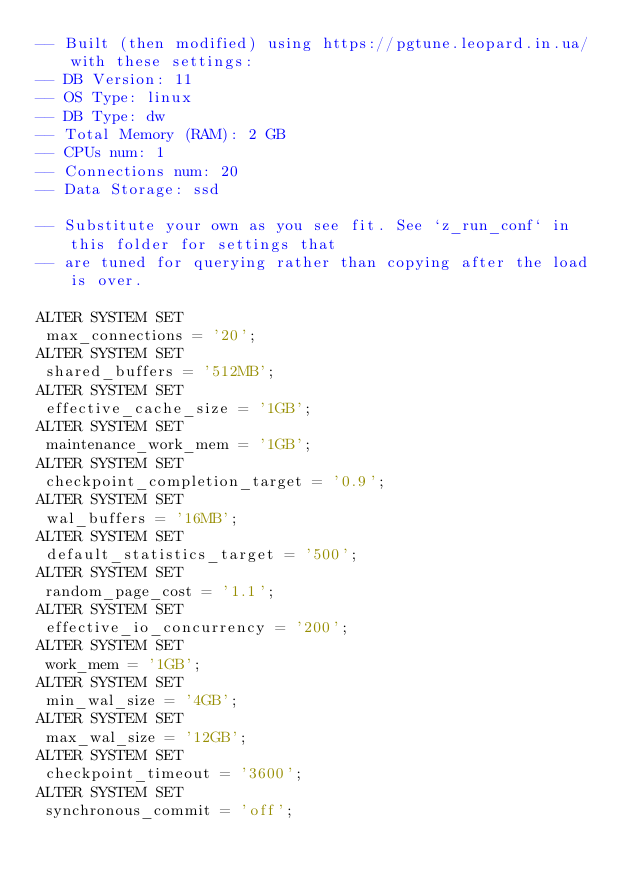Convert code to text. <code><loc_0><loc_0><loc_500><loc_500><_SQL_>-- Built (then modified) using https://pgtune.leopard.in.ua/ with these settings:
-- DB Version: 11
-- OS Type: linux
-- DB Type: dw
-- Total Memory (RAM): 2 GB
-- CPUs num: 1
-- Connections num: 20
-- Data Storage: ssd

-- Substitute your own as you see fit. See `z_run_conf` in this folder for settings that
-- are tuned for querying rather than copying after the load is over.

ALTER SYSTEM SET
 max_connections = '20';
ALTER SYSTEM SET
 shared_buffers = '512MB';
ALTER SYSTEM SET
 effective_cache_size = '1GB';
ALTER SYSTEM SET
 maintenance_work_mem = '1GB';
ALTER SYSTEM SET
 checkpoint_completion_target = '0.9';
ALTER SYSTEM SET
 wal_buffers = '16MB';
ALTER SYSTEM SET
 default_statistics_target = '500';
ALTER SYSTEM SET
 random_page_cost = '1.1';
ALTER SYSTEM SET
 effective_io_concurrency = '200';
ALTER SYSTEM SET
 work_mem = '1GB';
ALTER SYSTEM SET
 min_wal_size = '4GB';
ALTER SYSTEM SET
 max_wal_size = '12GB';
ALTER SYSTEM SET
 checkpoint_timeout = '3600';
ALTER SYSTEM SET
 synchronous_commit = 'off';</code> 